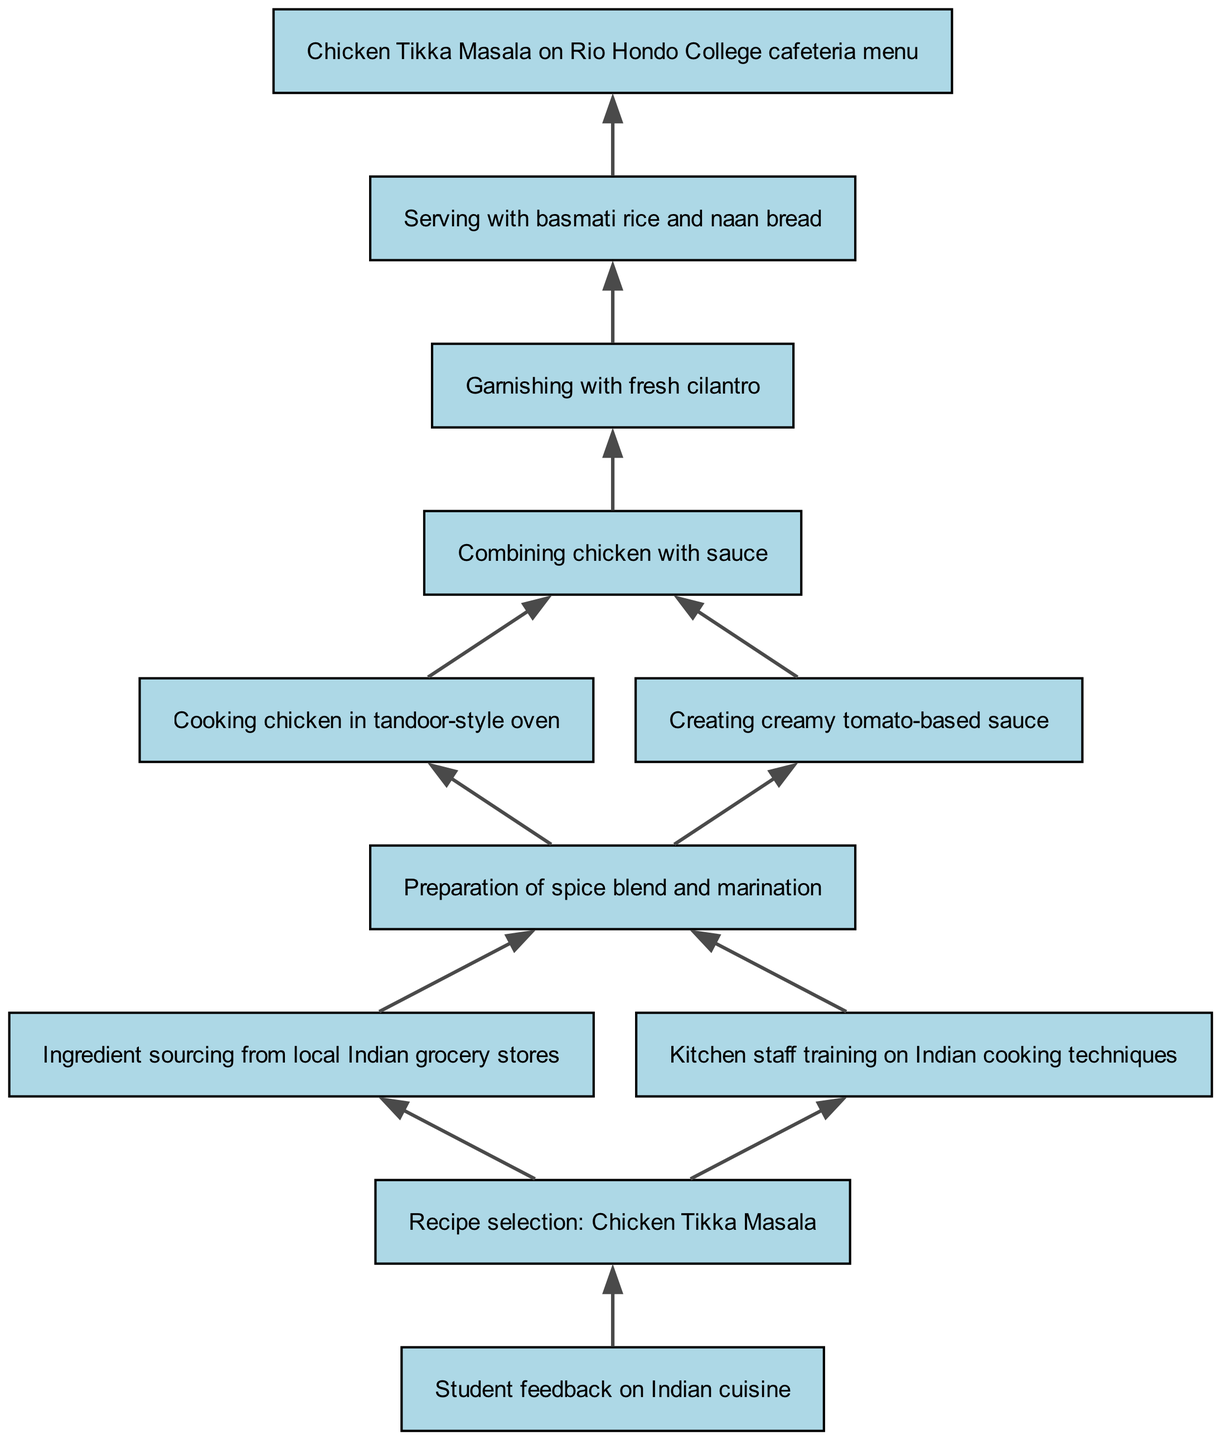What dish is selected after student feedback? The first step in the diagram is "Student feedback on Indian cuisine," which leads to the selection of a specific dish. The next node indicates the selected dish as "Recipe selection: Chicken Tikka Masala."
Answer: Chicken Tikka Masala How many ingredients are directly involved in preparing Chicken Tikka Masala? The diagram primarily focuses on the ingredient sourcing, preparation of spice blend, cooking, and garnishing. The nodes include "Ingredient sourcing from local Indian grocery stores," "Preparation of spice blend and marination," "Cooking chicken in tandoor-style oven," and "Creating creamy tomato-based sauce," which summarize key ingredients involved.
Answer: Four What is the first step in the preparation process? The diagram starts with "Student feedback on Indian cuisine," which initiates the journey towards the dish being served. This feedback informs the recipe selection.
Answer: Student feedback on Indian cuisine Which step involves combining chicken with sauce? The relevant node in the flow chart that directly mentions the combination occurs after the cooking steps. Upon cooking, the next step is "Combining chicken with sauce," indicating that this is where the chicken is integrated with the previously made sauce.
Answer: Combining chicken with sauce What is served with Chicken Tikka Masala at the cafeteria? The final preparation step concludes with "Serving with basmati rice and naan bread," which directly answers the question about what accompanies the dish when served.
Answer: Basmati rice and naan bread How many training steps are mentioned in the diagram? There is one training step in the diagram, identified as "Kitchen staff training on Indian cooking techniques." This node highlights a key requirement in the process but does not reoccur, thereby indicating the singular training step.
Answer: One 